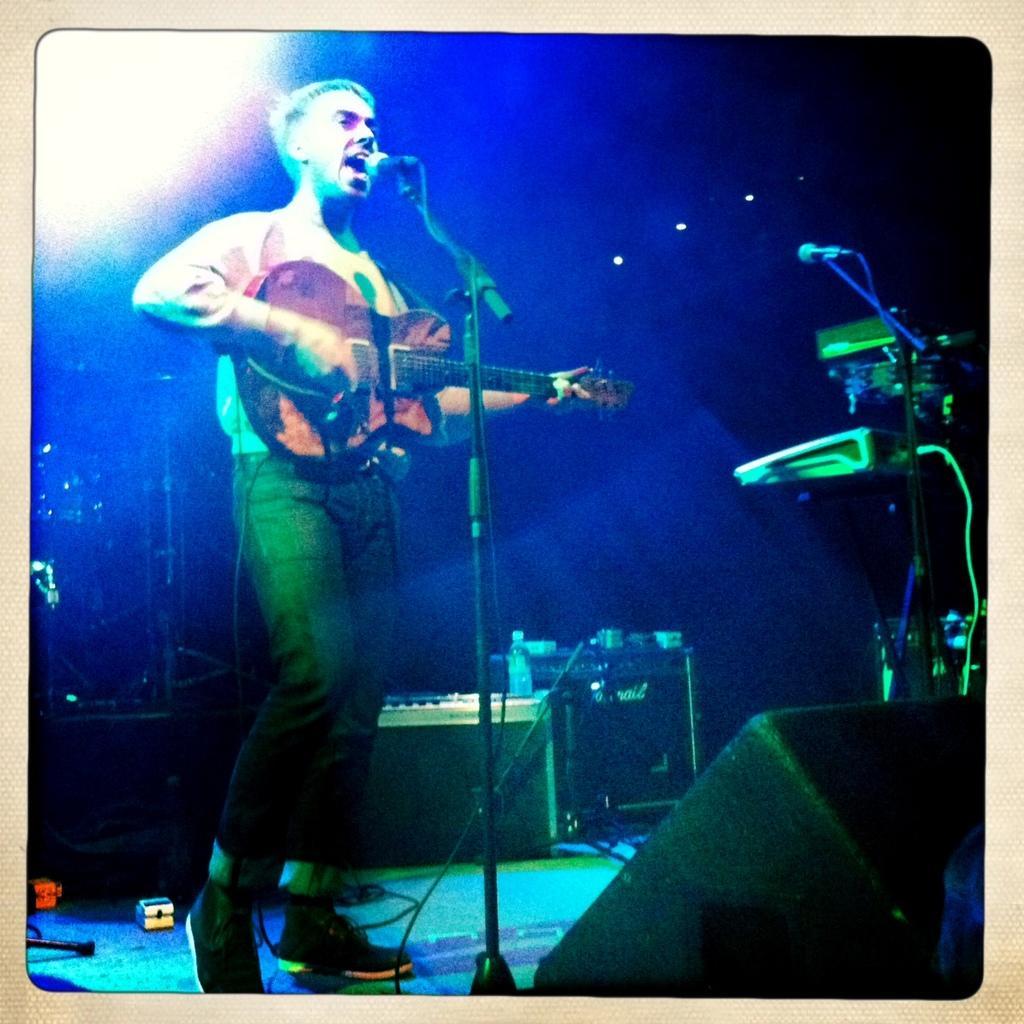In one or two sentences, can you explain what this image depicts? In this image I can see a person standing and holding guitar in his hands in front of a mike looks like he is singing. Behind him I can see some objects, before him I can see a mike and some electrical devices. In the top left corner ,I can see the light. 